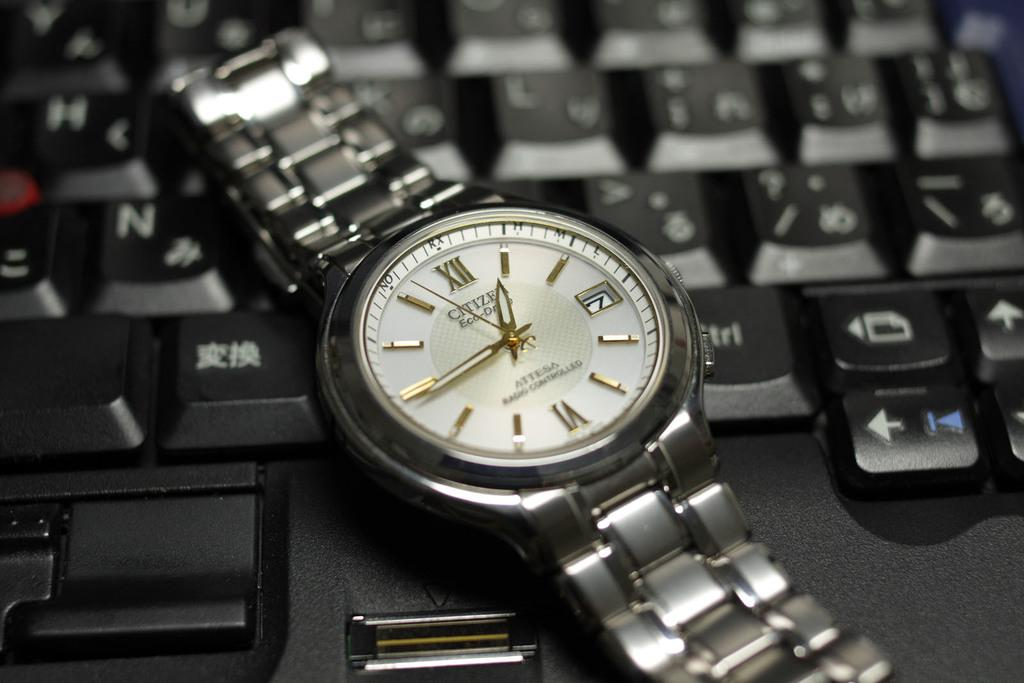Provide a one-sentence caption for the provided image. A metal band Citizen Eco Drive watch on a laptop keyboard. 